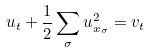Convert formula to latex. <formula><loc_0><loc_0><loc_500><loc_500>u _ { t } + \frac { 1 } { 2 } \sum _ { \sigma } u _ { x _ { \sigma } } ^ { 2 } = v _ { t }</formula> 